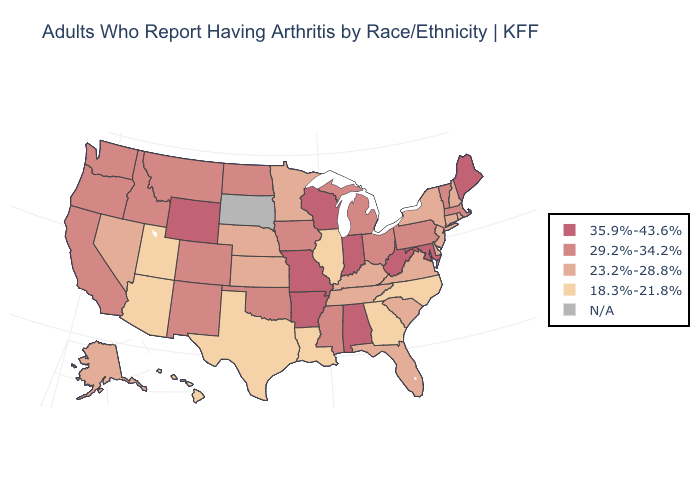Does the map have missing data?
Write a very short answer. Yes. Is the legend a continuous bar?
Short answer required. No. Does the first symbol in the legend represent the smallest category?
Quick response, please. No. What is the lowest value in the Northeast?
Quick response, please. 23.2%-28.8%. What is the lowest value in states that border Utah?
Quick response, please. 18.3%-21.8%. Among the states that border Wisconsin , does Minnesota have the highest value?
Be succinct. No. What is the value of Delaware?
Short answer required. 23.2%-28.8%. What is the value of California?
Keep it brief. 29.2%-34.2%. What is the value of Indiana?
Short answer required. 35.9%-43.6%. What is the highest value in the USA?
Be succinct. 35.9%-43.6%. Name the states that have a value in the range N/A?
Keep it brief. South Dakota. 